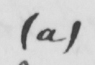Please transcribe the handwritten text in this image. ( a ) 